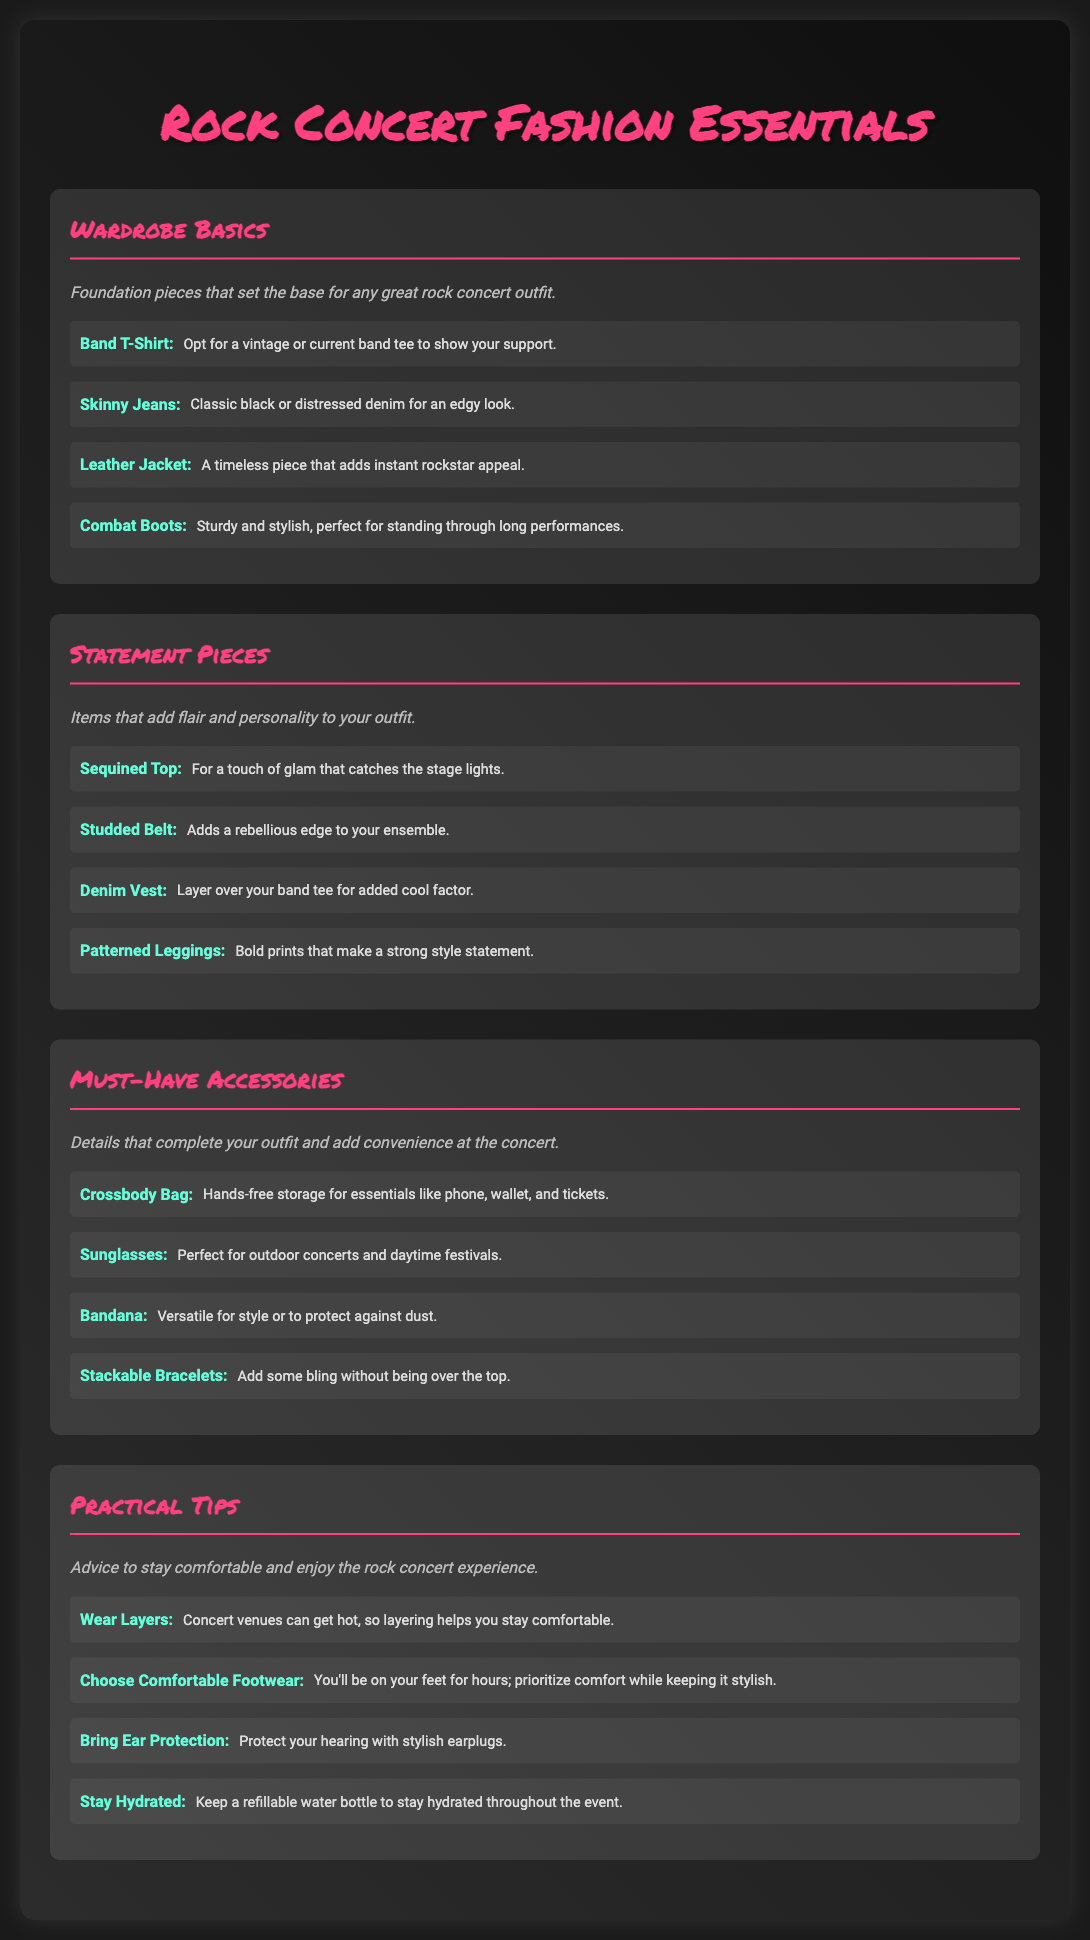What are the wardrobe basics mentioned? The wardrobe basics are foundational pieces listed under that section in the document.
Answer: Band T-Shirt, Skinny Jeans, Leather Jacket, Combat Boots How many statement pieces are listed? The number of statement pieces can be counted from the section detailing them in the document.
Answer: 4 What should you wear for foot comfort? The document provides advice on footwear choices for comfort at concerts.
Answer: Comfortable Footwear What is an essential accessory for hands-free storage? The document explicitly mentions this accessory in the must-have accessories section.
Answer: Crossbody Bag What are the practical tips for concerts related to clothing? The practical tips section discusses clothing strategies for comfort during a concert.
Answer: Wear Layers Which fashion piece adds rockstar appeal? This piece is identified in the wardrobe basics section as enhancing style.
Answer: Leather Jacket What item is suggested for ear protection? The document lists this under practical tips for concertgoers.
Answer: Ear Protection What type of jeans is recommended for a rock concert? The specific type of jeans is mentioned under the wardrobe basics section.
Answer: Skinny Jeans How many must-have accessories are in the document? This can be determined by counting the items listed under that specific section.
Answer: 4 